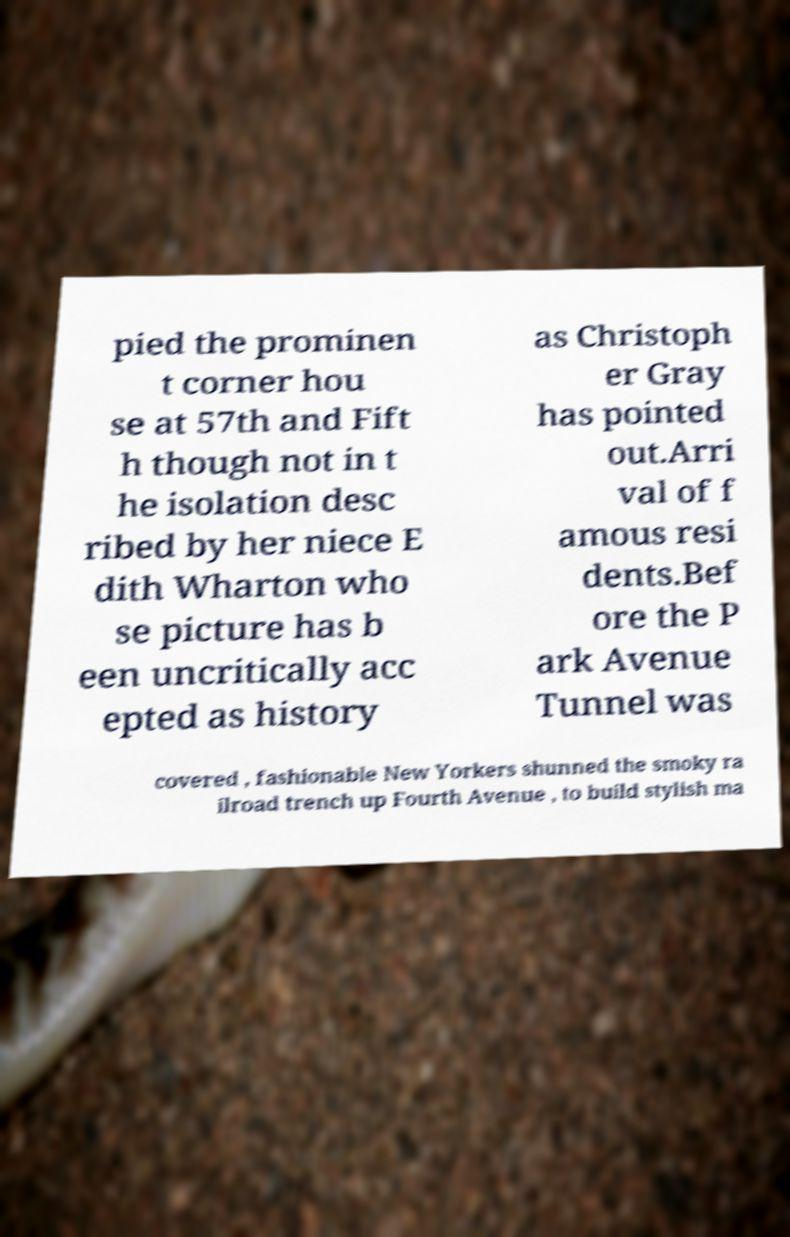I need the written content from this picture converted into text. Can you do that? pied the prominen t corner hou se at 57th and Fift h though not in t he isolation desc ribed by her niece E dith Wharton who se picture has b een uncritically acc epted as history as Christoph er Gray has pointed out.Arri val of f amous resi dents.Bef ore the P ark Avenue Tunnel was covered , fashionable New Yorkers shunned the smoky ra ilroad trench up Fourth Avenue , to build stylish ma 